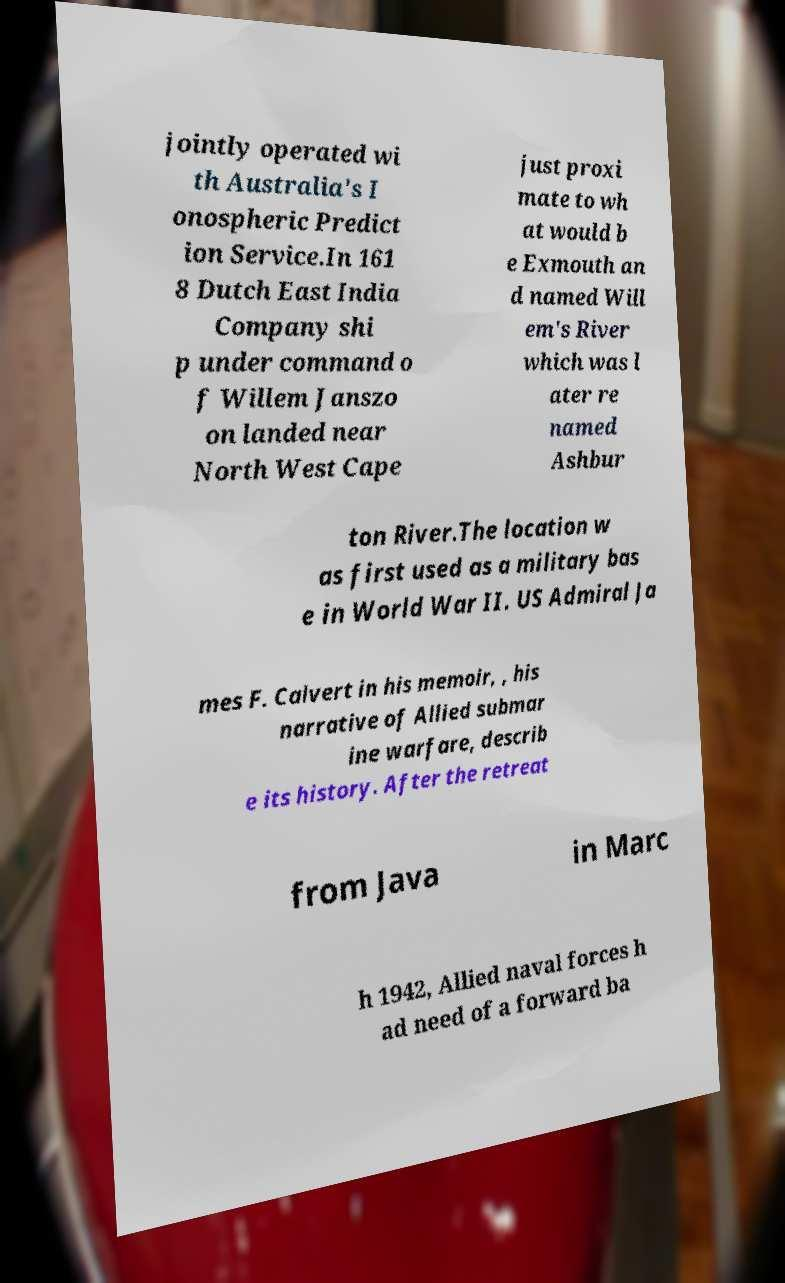Could you assist in decoding the text presented in this image and type it out clearly? jointly operated wi th Australia's I onospheric Predict ion Service.In 161 8 Dutch East India Company shi p under command o f Willem Janszo on landed near North West Cape just proxi mate to wh at would b e Exmouth an d named Will em's River which was l ater re named Ashbur ton River.The location w as first used as a military bas e in World War II. US Admiral Ja mes F. Calvert in his memoir, , his narrative of Allied submar ine warfare, describ e its history. After the retreat from Java in Marc h 1942, Allied naval forces h ad need of a forward ba 